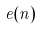Convert formula to latex. <formula><loc_0><loc_0><loc_500><loc_500>e ( n )</formula> 